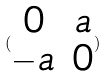Convert formula to latex. <formula><loc_0><loc_0><loc_500><loc_500>( \begin{matrix} 0 & a \\ - a & 0 \end{matrix} )</formula> 